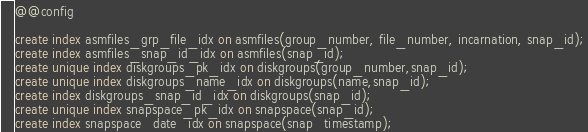<code> <loc_0><loc_0><loc_500><loc_500><_SQL_>
@@config

create index asmfiles_grp_file_idx on asmfiles(group_number, file_number, incarnation, snap_id);
create index asmfiles_snap_id_idx on asmfiles(snap_id);
create unique index diskgroups_pk_idx on diskgroups(group_number,snap_id);
create unique index diskgroups_name_idx on diskgroups(name,snap_id);
create index diskgroups_snap_id_idx on diskgroups(snap_id);
create unique index snapspace_pk_idx on snapspace(snap_id);
create index snapspace_date_idx on snapspace(snap_timestamp);


</code> 